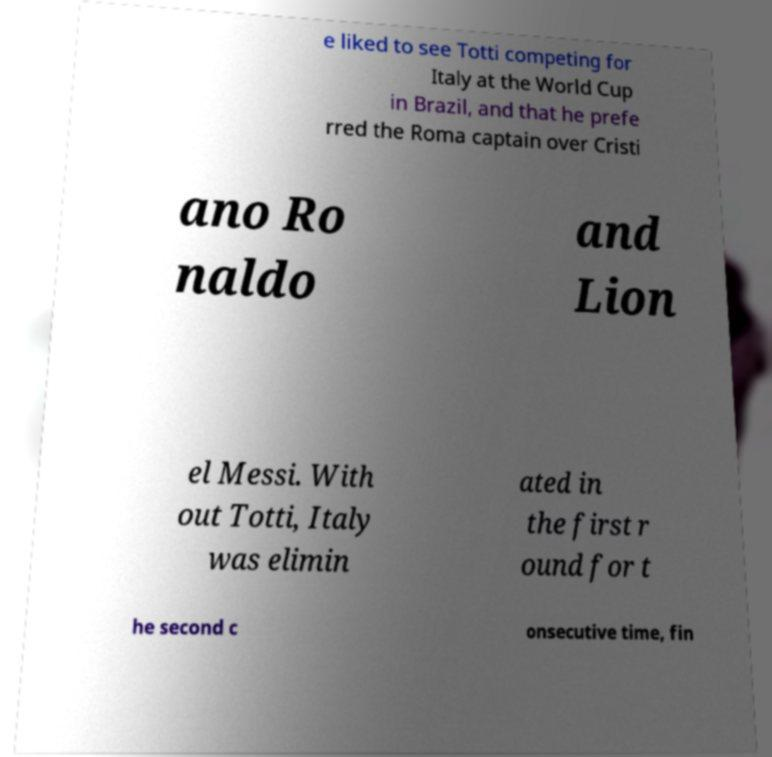Could you extract and type out the text from this image? e liked to see Totti competing for Italy at the World Cup in Brazil, and that he prefe rred the Roma captain over Cristi ano Ro naldo and Lion el Messi. With out Totti, Italy was elimin ated in the first r ound for t he second c onsecutive time, fin 